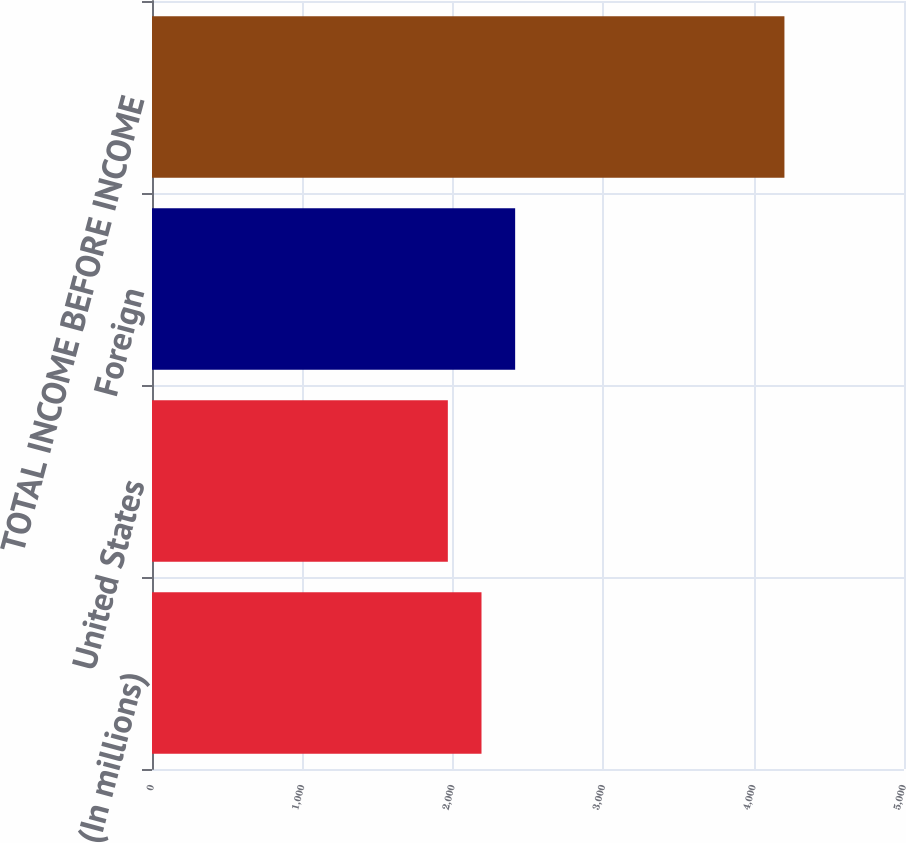Convert chart. <chart><loc_0><loc_0><loc_500><loc_500><bar_chart><fcel>(In millions)<fcel>United States<fcel>Foreign<fcel>TOTAL INCOME BEFORE INCOME<nl><fcel>2190.8<fcel>1967<fcel>2414.6<fcel>4205<nl></chart> 